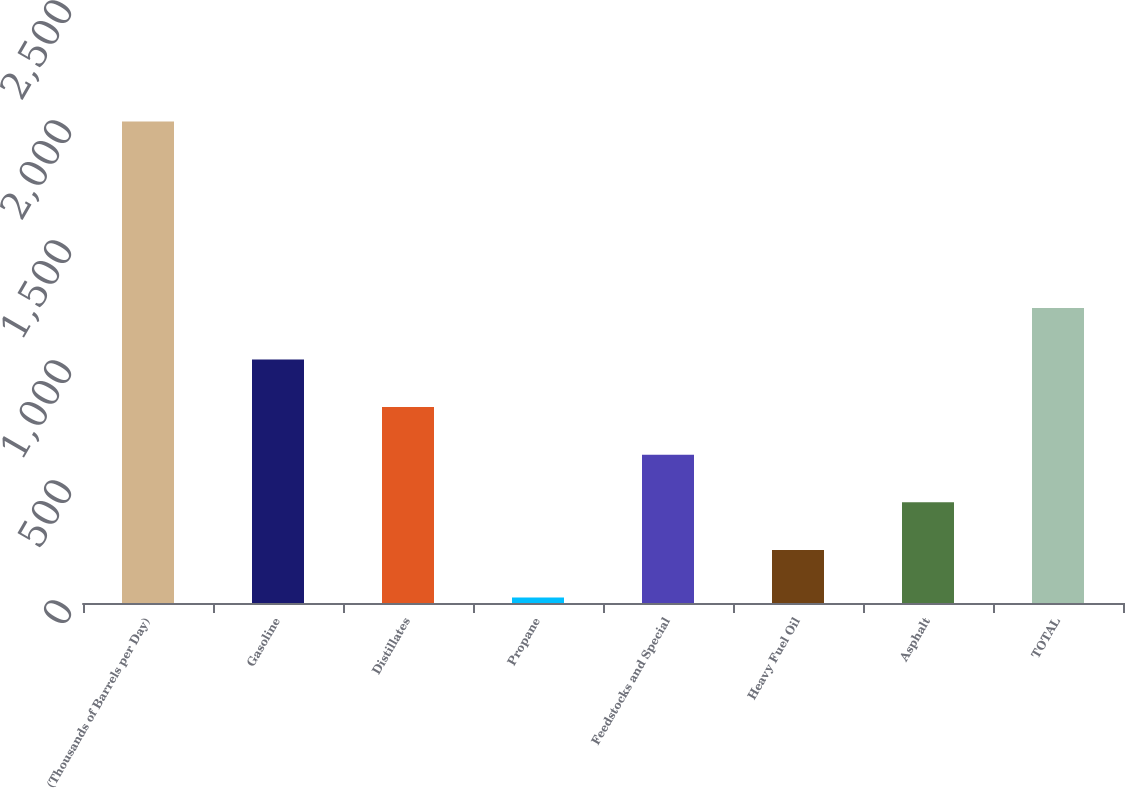<chart> <loc_0><loc_0><loc_500><loc_500><bar_chart><fcel>(Thousands of Barrels per Day)<fcel>Gasoline<fcel>Distillates<fcel>Propane<fcel>Feedstocks and Special<fcel>Heavy Fuel Oil<fcel>Asphalt<fcel>TOTAL<nl><fcel>2006<fcel>1014.5<fcel>816.2<fcel>23<fcel>617.9<fcel>221.3<fcel>419.6<fcel>1229<nl></chart> 